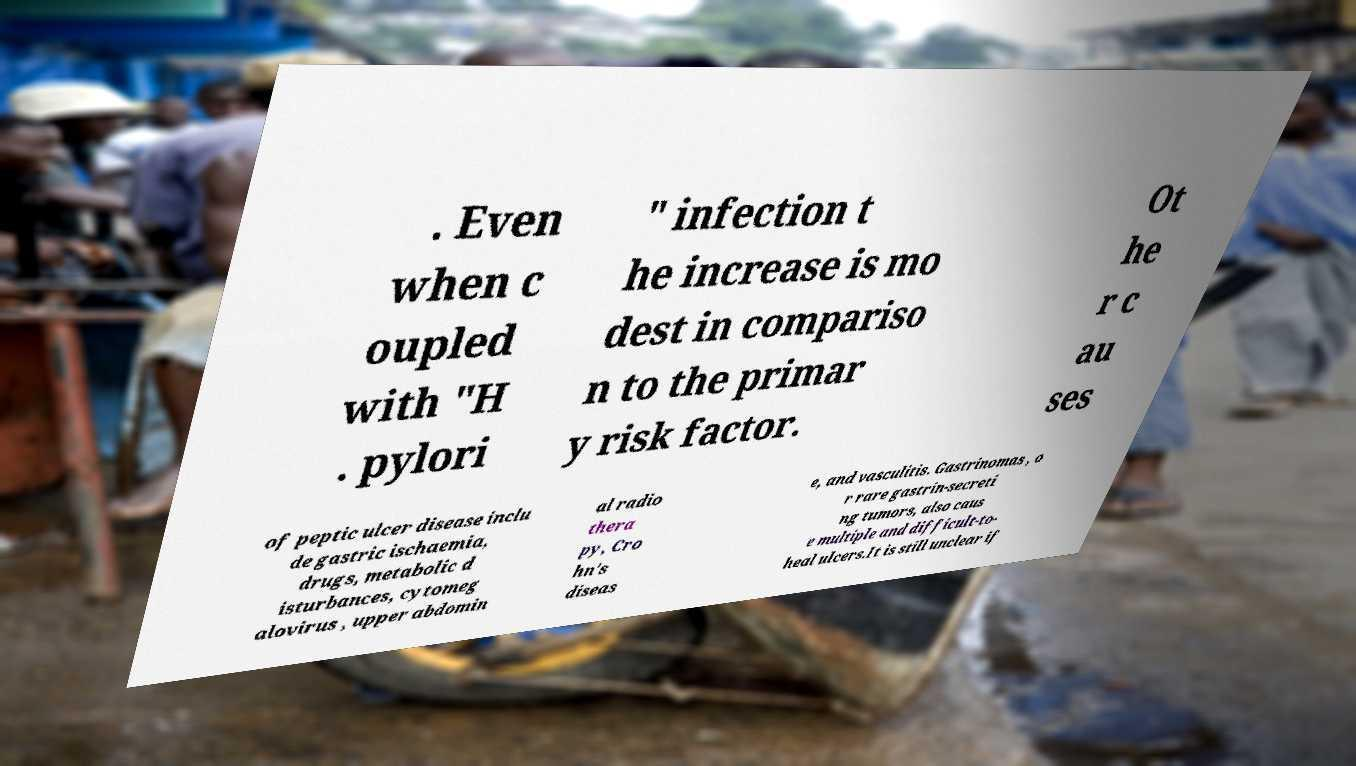Please identify and transcribe the text found in this image. . Even when c oupled with "H . pylori " infection t he increase is mo dest in compariso n to the primar y risk factor. Ot he r c au ses of peptic ulcer disease inclu de gastric ischaemia, drugs, metabolic d isturbances, cytomeg alovirus , upper abdomin al radio thera py, Cro hn's diseas e, and vasculitis. Gastrinomas , o r rare gastrin-secreti ng tumors, also caus e multiple and difficult-to- heal ulcers.It is still unclear if 